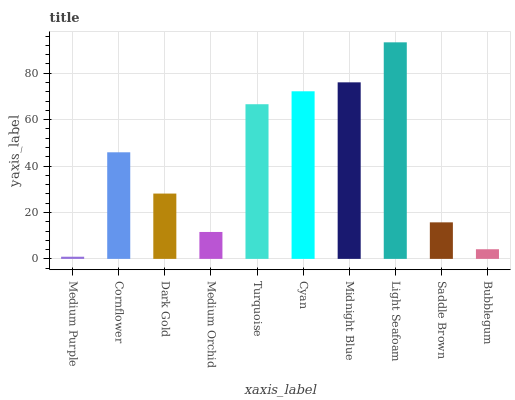Is Medium Purple the minimum?
Answer yes or no. Yes. Is Light Seafoam the maximum?
Answer yes or no. Yes. Is Cornflower the minimum?
Answer yes or no. No. Is Cornflower the maximum?
Answer yes or no. No. Is Cornflower greater than Medium Purple?
Answer yes or no. Yes. Is Medium Purple less than Cornflower?
Answer yes or no. Yes. Is Medium Purple greater than Cornflower?
Answer yes or no. No. Is Cornflower less than Medium Purple?
Answer yes or no. No. Is Cornflower the high median?
Answer yes or no. Yes. Is Dark Gold the low median?
Answer yes or no. Yes. Is Medium Purple the high median?
Answer yes or no. No. Is Light Seafoam the low median?
Answer yes or no. No. 